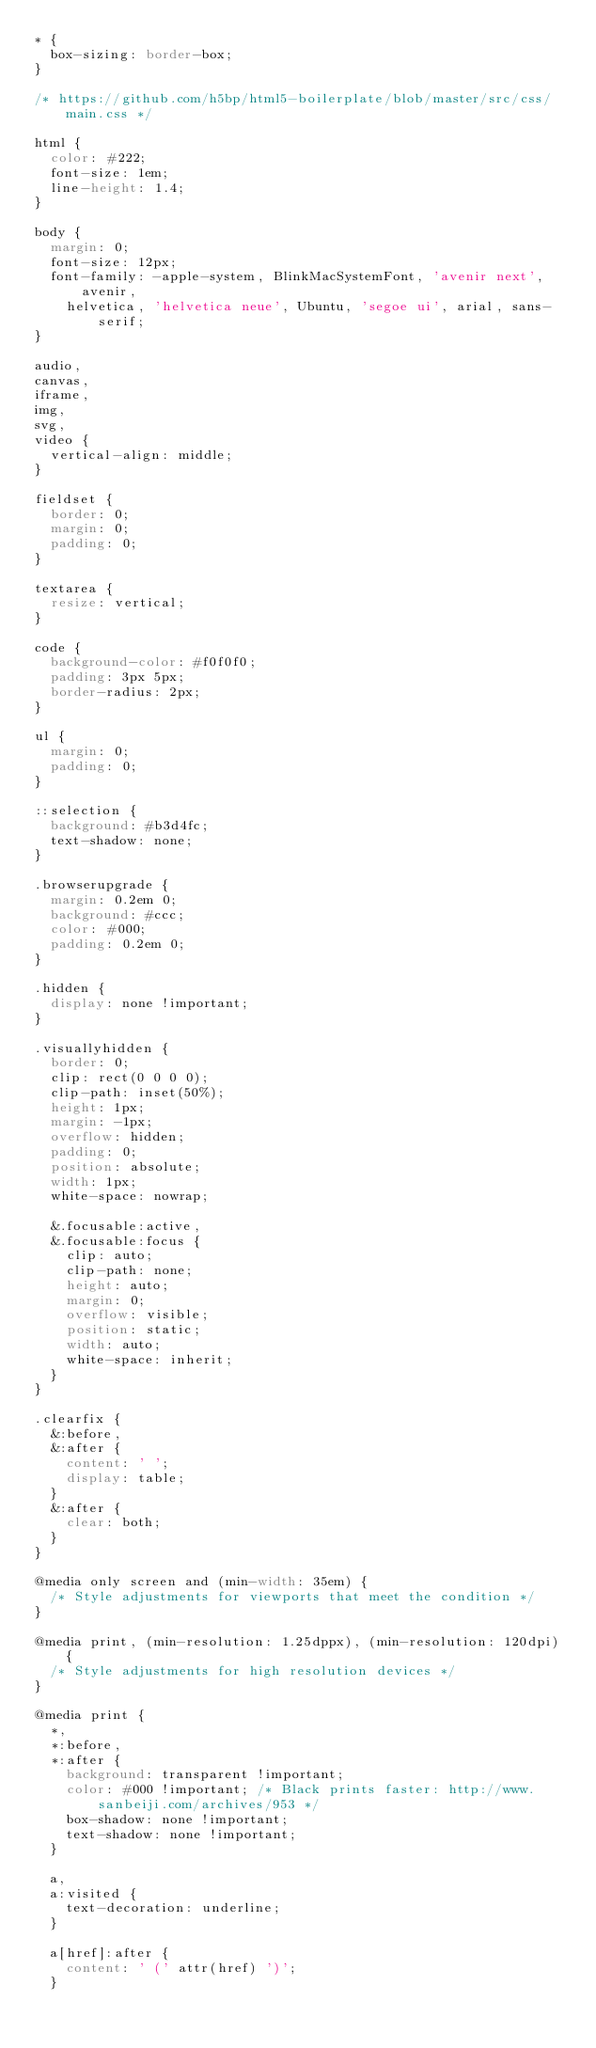<code> <loc_0><loc_0><loc_500><loc_500><_CSS_>* {
  box-sizing: border-box;
}

/* https://github.com/h5bp/html5-boilerplate/blob/master/src/css/main.css */

html {
  color: #222;
  font-size: 1em;
  line-height: 1.4;
}

body {
  margin: 0;
  font-size: 12px;
  font-family: -apple-system, BlinkMacSystemFont, 'avenir next', avenir,
    helvetica, 'helvetica neue', Ubuntu, 'segoe ui', arial, sans-serif;
}

audio,
canvas,
iframe,
img,
svg,
video {
  vertical-align: middle;
}

fieldset {
  border: 0;
  margin: 0;
  padding: 0;
}

textarea {
  resize: vertical;
}

code {
  background-color: #f0f0f0;
  padding: 3px 5px;
  border-radius: 2px;
}

ul {
  margin: 0;
  padding: 0;
}

::selection {
  background: #b3d4fc;
  text-shadow: none;
}

.browserupgrade {
  margin: 0.2em 0;
  background: #ccc;
  color: #000;
  padding: 0.2em 0;
}

.hidden {
  display: none !important;
}

.visuallyhidden {
  border: 0;
  clip: rect(0 0 0 0);
  clip-path: inset(50%);
  height: 1px;
  margin: -1px;
  overflow: hidden;
  padding: 0;
  position: absolute;
  width: 1px;
  white-space: nowrap;

  &.focusable:active,
  &.focusable:focus {
    clip: auto;
    clip-path: none;
    height: auto;
    margin: 0;
    overflow: visible;
    position: static;
    width: auto;
    white-space: inherit;
  }
}

.clearfix {
  &:before,
  &:after {
    content: ' ';
    display: table;
  }
  &:after {
    clear: both;
  }
}

@media only screen and (min-width: 35em) {
  /* Style adjustments for viewports that meet the condition */
}

@media print, (min-resolution: 1.25dppx), (min-resolution: 120dpi) {
  /* Style adjustments for high resolution devices */
}

@media print {
  *,
  *:before,
  *:after {
    background: transparent !important;
    color: #000 !important; /* Black prints faster: http://www.sanbeiji.com/archives/953 */
    box-shadow: none !important;
    text-shadow: none !important;
  }

  a,
  a:visited {
    text-decoration: underline;
  }

  a[href]:after {
    content: ' (' attr(href) ')';
  }
</code> 